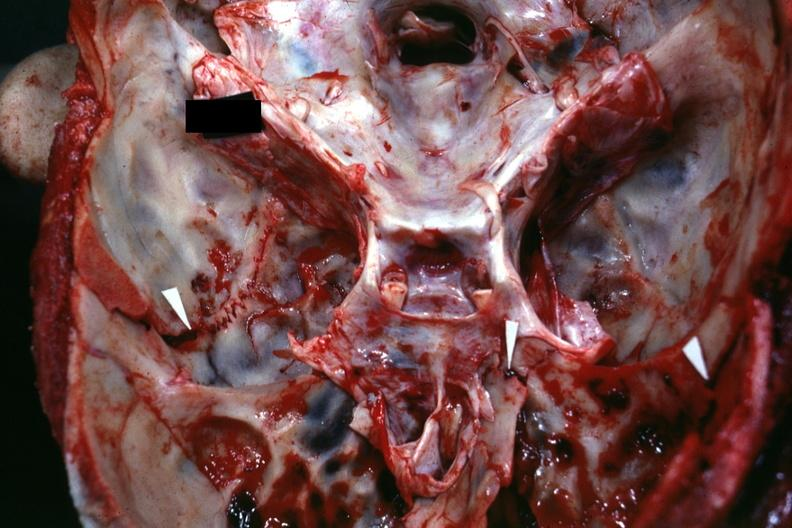does amyloid angiopathy r. endocrine show close-up view of base of skull with several well shown fractures?
Answer the question using a single word or phrase. No 